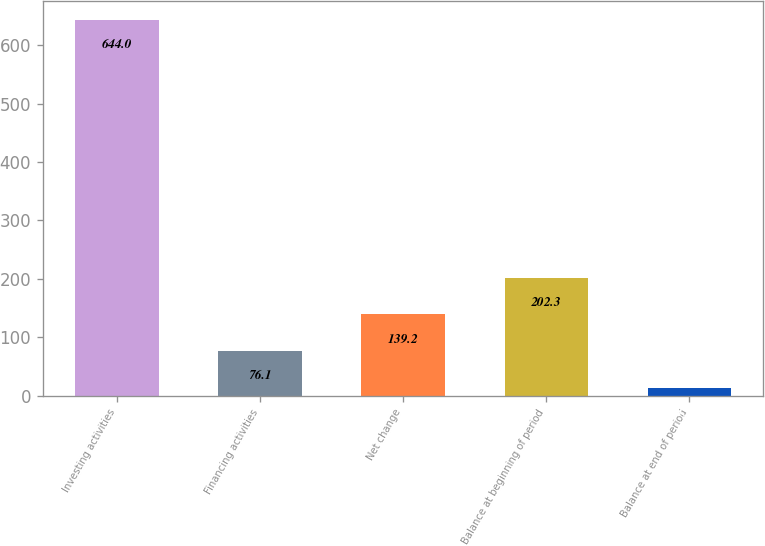<chart> <loc_0><loc_0><loc_500><loc_500><bar_chart><fcel>Investing activities<fcel>Financing activities<fcel>Net change<fcel>Balance at beginning of period<fcel>Balance at end of period<nl><fcel>644<fcel>76.1<fcel>139.2<fcel>202.3<fcel>13<nl></chart> 